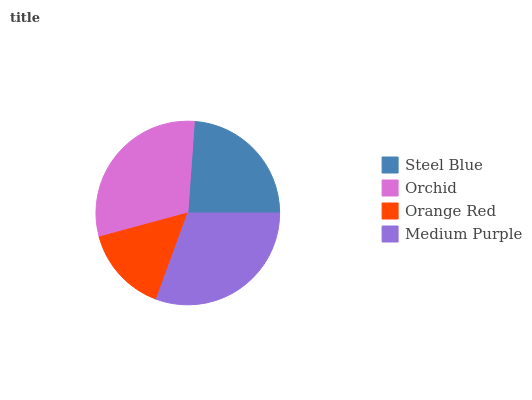Is Orange Red the minimum?
Answer yes or no. Yes. Is Medium Purple the maximum?
Answer yes or no. Yes. Is Orchid the minimum?
Answer yes or no. No. Is Orchid the maximum?
Answer yes or no. No. Is Orchid greater than Steel Blue?
Answer yes or no. Yes. Is Steel Blue less than Orchid?
Answer yes or no. Yes. Is Steel Blue greater than Orchid?
Answer yes or no. No. Is Orchid less than Steel Blue?
Answer yes or no. No. Is Orchid the high median?
Answer yes or no. Yes. Is Steel Blue the low median?
Answer yes or no. Yes. Is Medium Purple the high median?
Answer yes or no. No. Is Orange Red the low median?
Answer yes or no. No. 